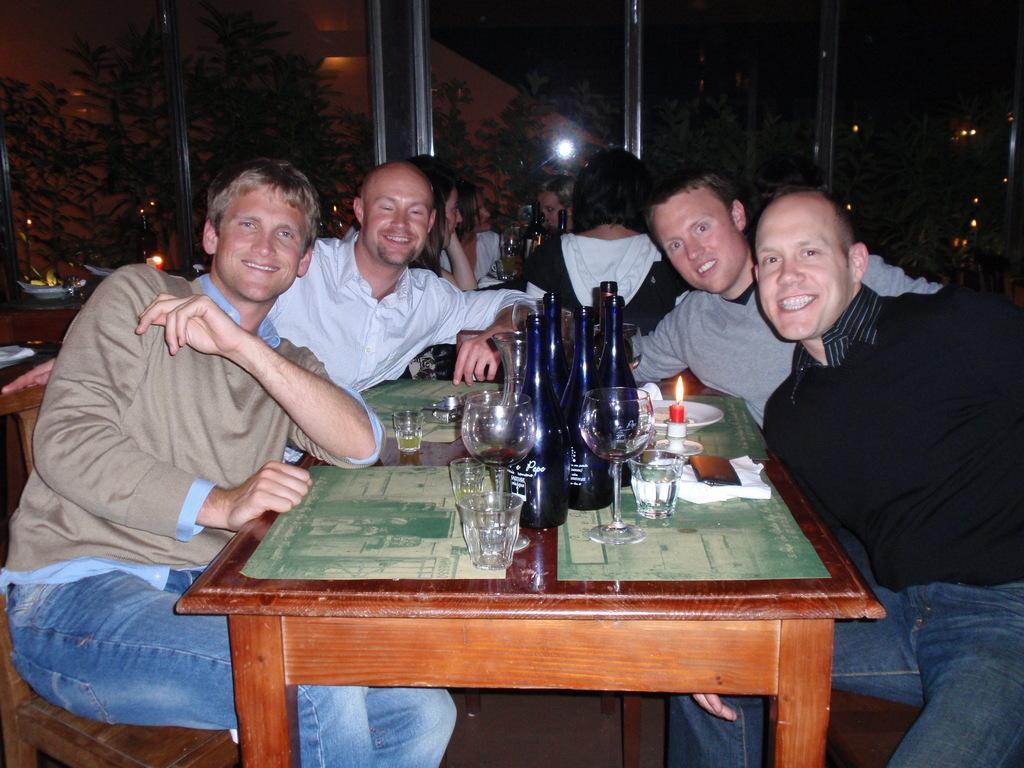Can you describe this image briefly? In this image i can see few persons sitting on chairs around the table. On the table i can see few glasses, few bottles, a mobile, a plate, few tissues and the candle. In the background i can see few trees, dark sky and few other people sitting on chairs. 